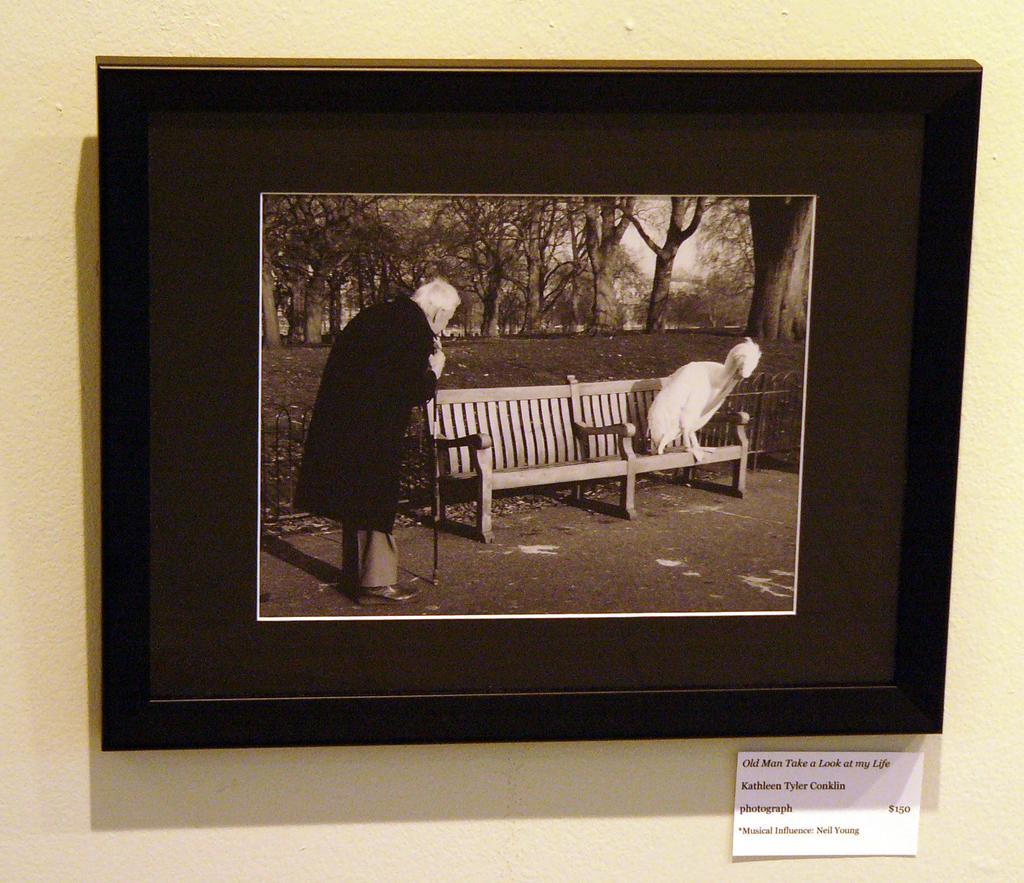Describe this image in one or two sentences. This is a photo frame on the wall. In the photo there is an old man holding stick in his hand and a chair on which there is an animal. In the background there are many trees. At the bottom there is a tag. 